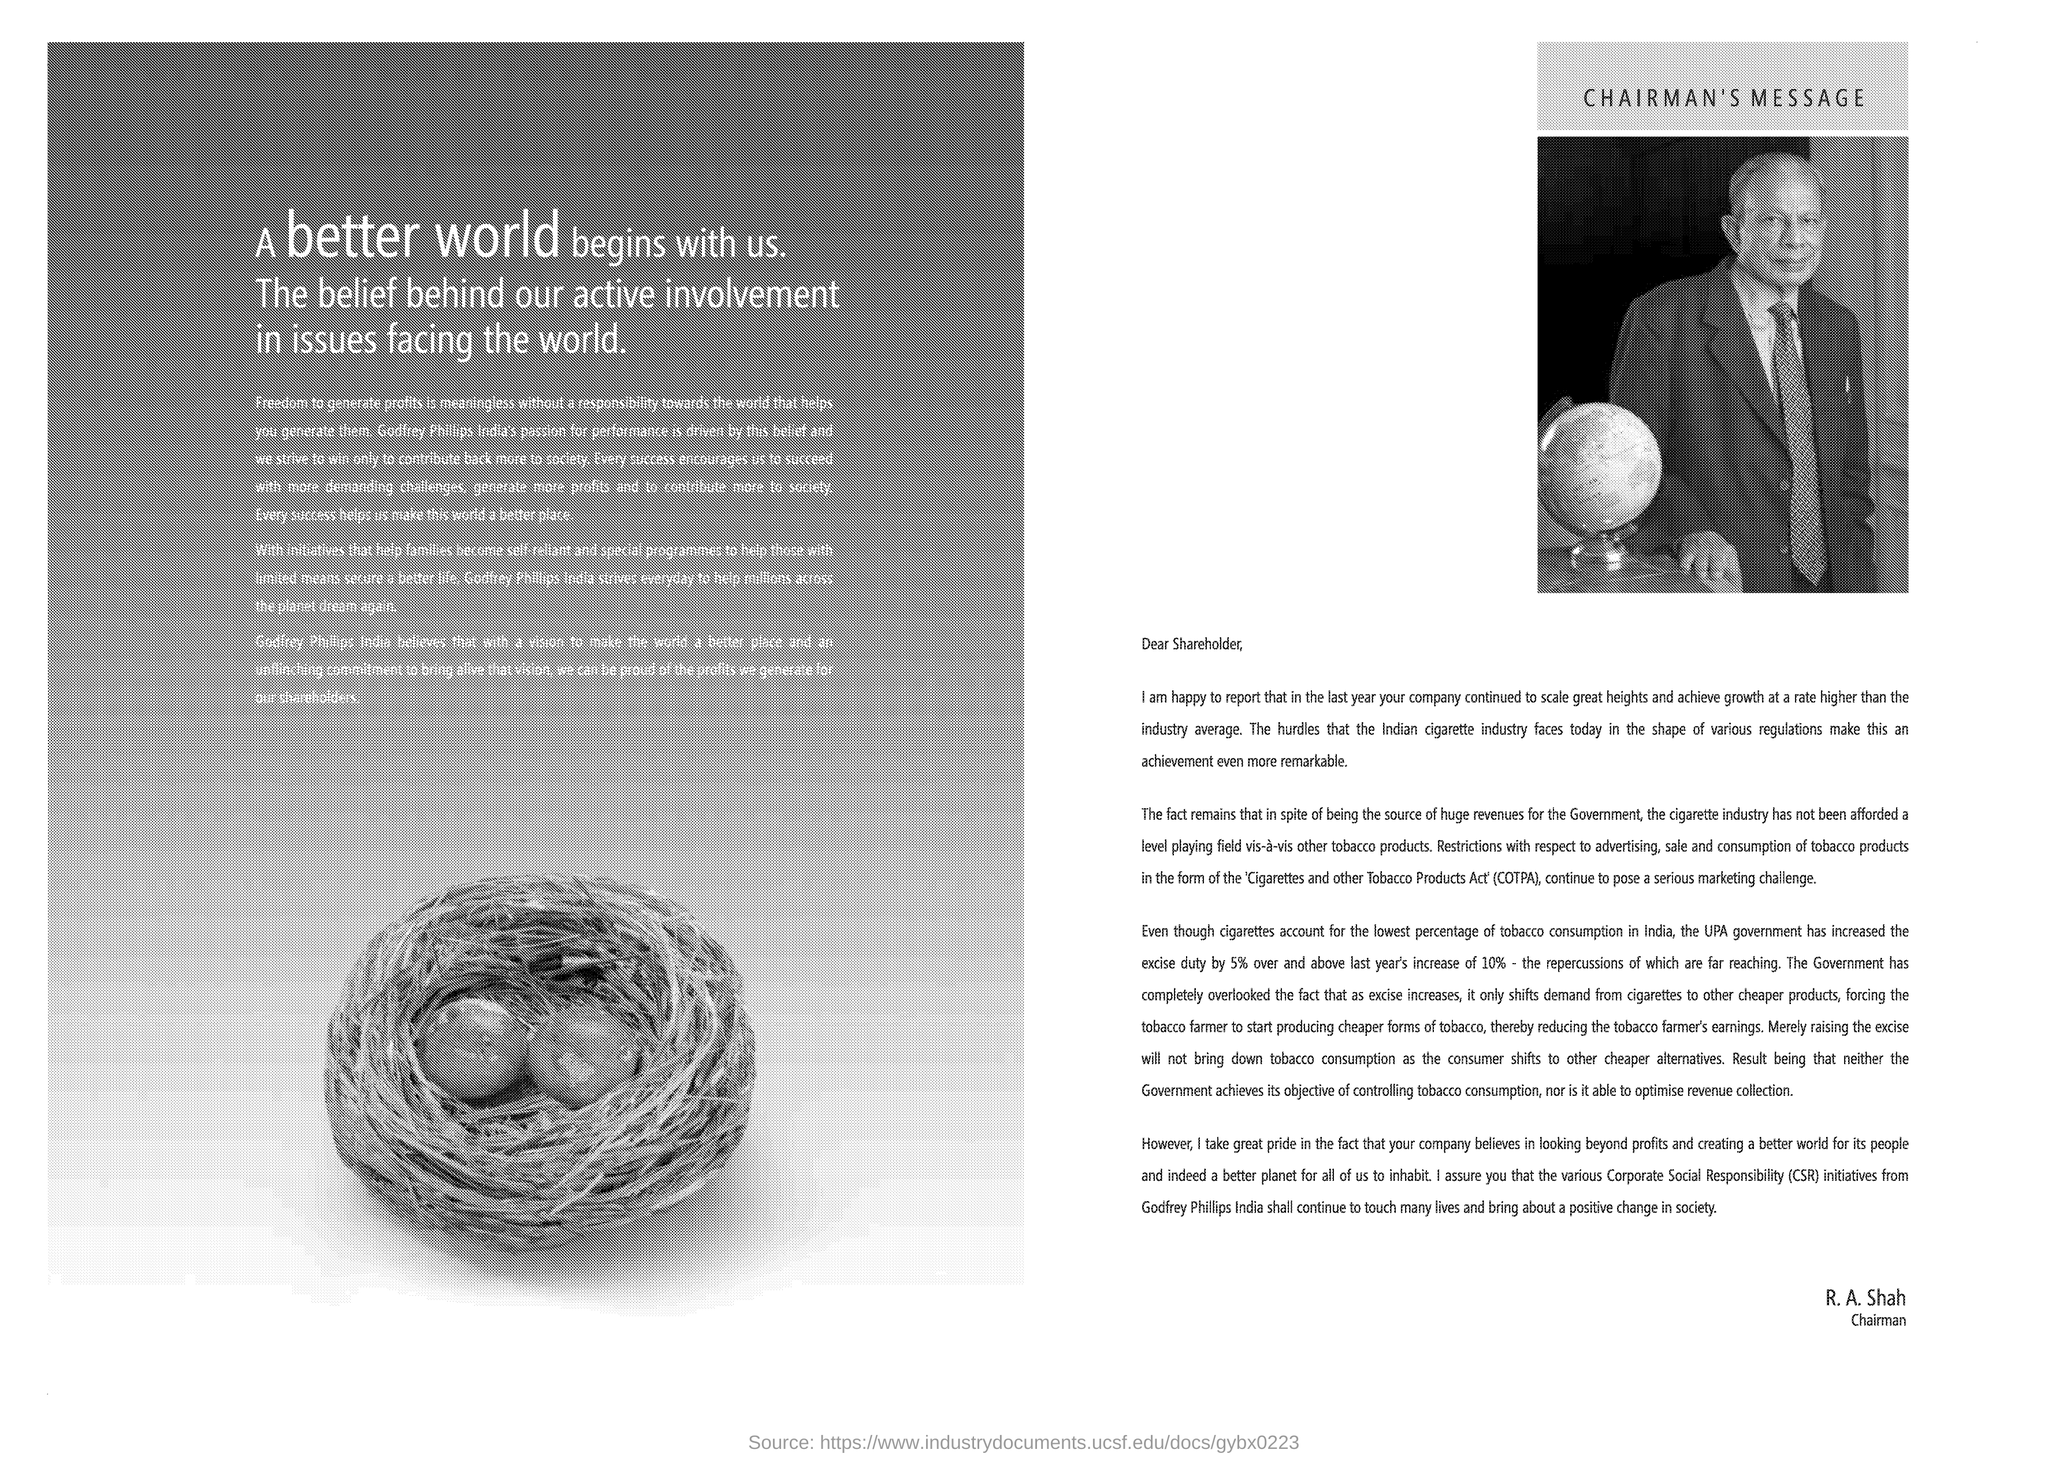What was the percentage increase of excise duty last year?
Provide a short and direct response. 10. Why merely raising the excise duty will not bring down tobacco consumption?
Your answer should be compact. As the consumer shifts to other cheaper alternatives. 